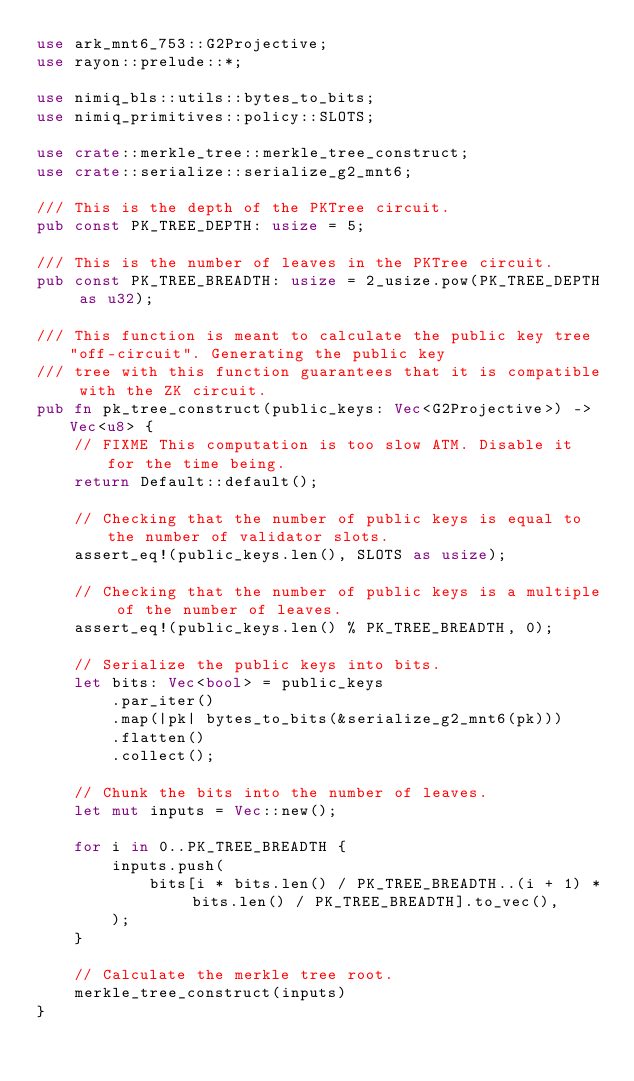Convert code to text. <code><loc_0><loc_0><loc_500><loc_500><_Rust_>use ark_mnt6_753::G2Projective;
use rayon::prelude::*;

use nimiq_bls::utils::bytes_to_bits;
use nimiq_primitives::policy::SLOTS;

use crate::merkle_tree::merkle_tree_construct;
use crate::serialize::serialize_g2_mnt6;

/// This is the depth of the PKTree circuit.
pub const PK_TREE_DEPTH: usize = 5;

/// This is the number of leaves in the PKTree circuit.
pub const PK_TREE_BREADTH: usize = 2_usize.pow(PK_TREE_DEPTH as u32);

/// This function is meant to calculate the public key tree "off-circuit". Generating the public key
/// tree with this function guarantees that it is compatible with the ZK circuit.
pub fn pk_tree_construct(public_keys: Vec<G2Projective>) -> Vec<u8> {
    // FIXME This computation is too slow ATM. Disable it for the time being.
    return Default::default();

    // Checking that the number of public keys is equal to the number of validator slots.
    assert_eq!(public_keys.len(), SLOTS as usize);

    // Checking that the number of public keys is a multiple of the number of leaves.
    assert_eq!(public_keys.len() % PK_TREE_BREADTH, 0);

    // Serialize the public keys into bits.
    let bits: Vec<bool> = public_keys
        .par_iter()
        .map(|pk| bytes_to_bits(&serialize_g2_mnt6(pk)))
        .flatten()
        .collect();

    // Chunk the bits into the number of leaves.
    let mut inputs = Vec::new();

    for i in 0..PK_TREE_BREADTH {
        inputs.push(
            bits[i * bits.len() / PK_TREE_BREADTH..(i + 1) * bits.len() / PK_TREE_BREADTH].to_vec(),
        );
    }

    // Calculate the merkle tree root.
    merkle_tree_construct(inputs)
}
</code> 